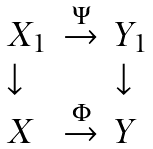<formula> <loc_0><loc_0><loc_500><loc_500>\begin{array} { l l l } X _ { 1 } & \stackrel { \Psi } { \rightarrow } & Y _ { 1 } \\ \downarrow & & \downarrow \\ X & \stackrel { \Phi } { \rightarrow } & Y \end{array}</formula> 